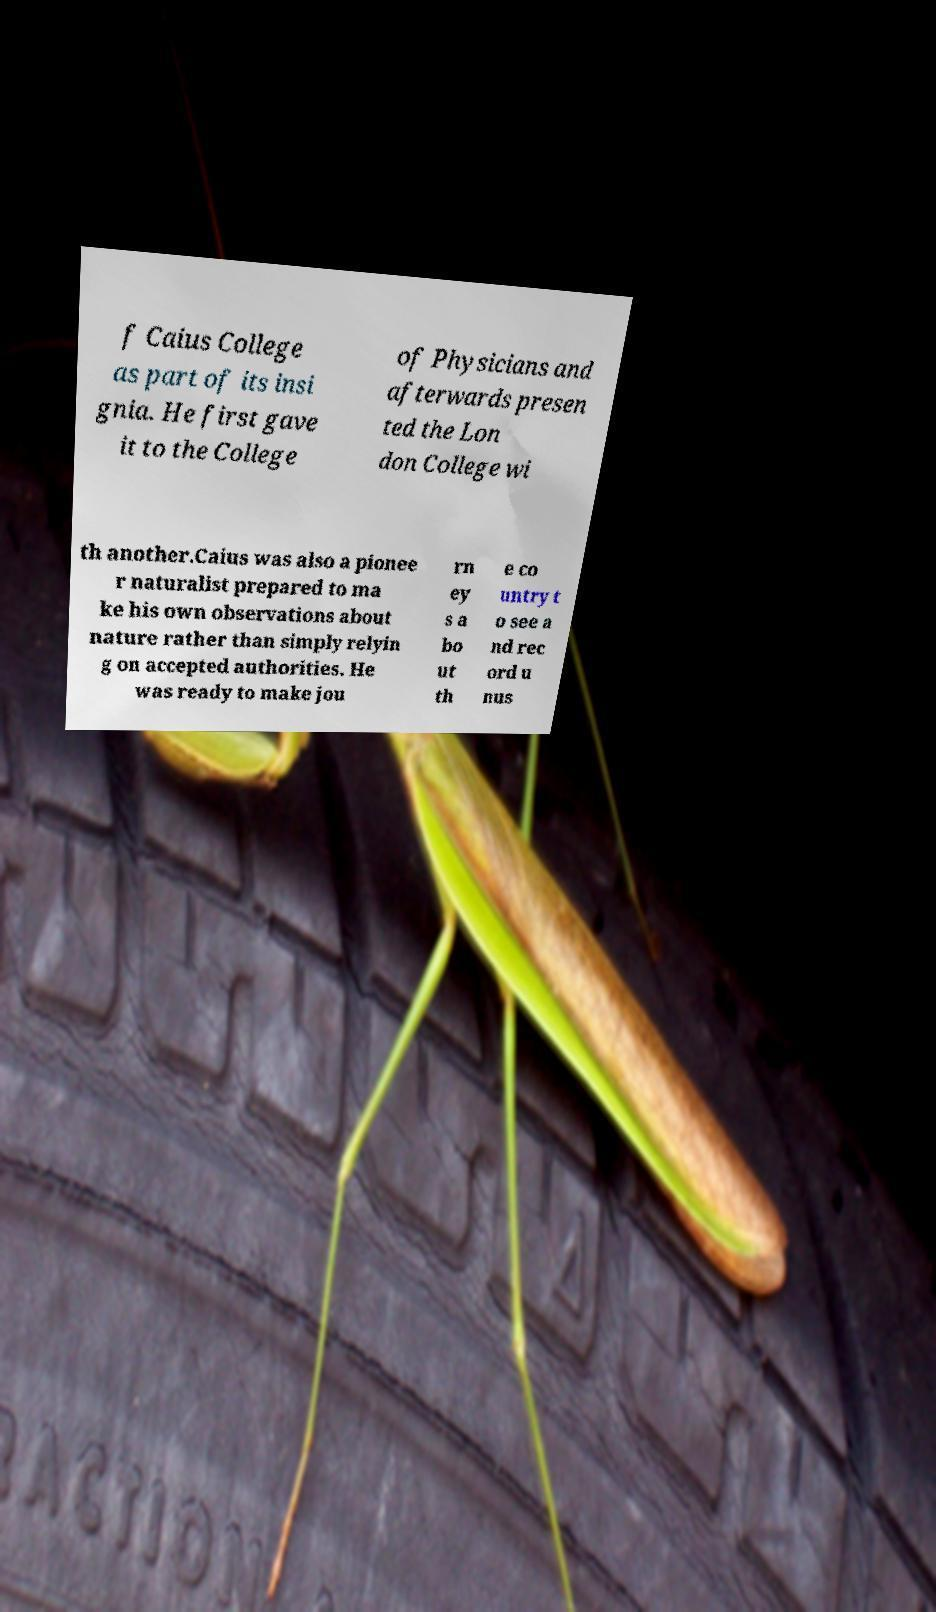There's text embedded in this image that I need extracted. Can you transcribe it verbatim? f Caius College as part of its insi gnia. He first gave it to the College of Physicians and afterwards presen ted the Lon don College wi th another.Caius was also a pionee r naturalist prepared to ma ke his own observations about nature rather than simply relyin g on accepted authorities. He was ready to make jou rn ey s a bo ut th e co untry t o see a nd rec ord u nus 